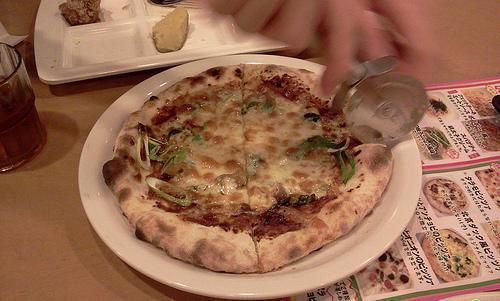How many full pizzas are visible?
Give a very brief answer. 1. 